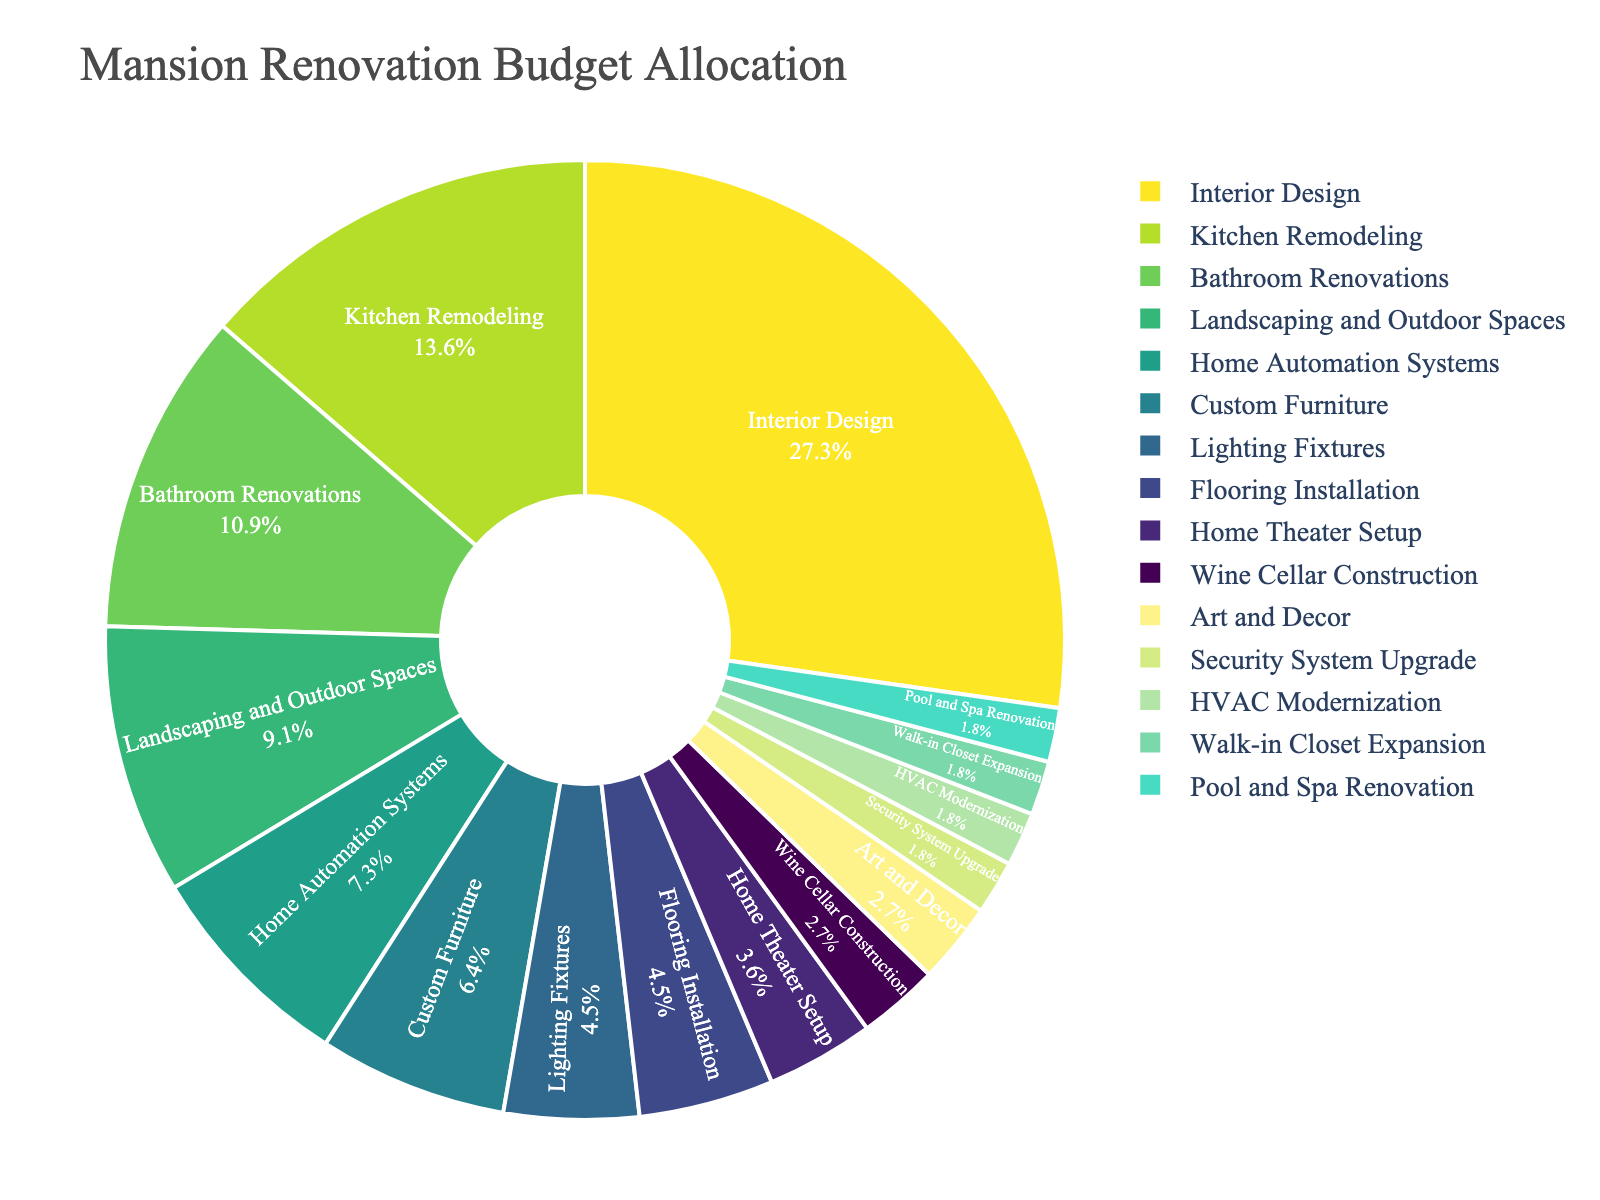What percentage of the budget is allocated to Interior Design? Look at the slice labeled "Interior Design" in the pie chart and read the percentage value directly.
Answer: 30% Is the budget for Kitchen Remodeling greater than that for Bathroom Renovations? Compare the slices labeled "Kitchen Remodeling" and "Bathroom Renovations" in the pie chart. Kitchen Remodeling has a budget of 15%, while Bathroom Renovations have 12%.
Answer: Yes What is the combined budget allocation for Lighting Fixtures, Flooring Installation, and Home Theater Setup? Sum the individual percentages from the pie chart. Lighting Fixtures (5%) + Flooring Installation (5%) + Home Theater Setup (4%) = 14%.
Answer: 14% How much more budget percentage is allocated to Landscaping and Outdoor Spaces compared to Wine Cellar Construction? Subtract the budget percentage of Wine Cellar Construction (3%) from Landscaping and Outdoor Spaces (10%). 10% - 3% = 7%.
Answer: 7% Which has a higher budget allocation, Custom Furniture or Home Automation Systems? Compare the slices for Custom Furniture (7%) and Home Automation Systems (8%) in the pie chart.
Answer: Home Automation Systems Rank the following areas from highest to lowest by budget allocation: Art and Decor, HVAC Modernization, Walk-in Closet Expansion. Refer to the individual slices for Art and Decor (3%), HVAC Modernization (2%), and Walk-in Closet Expansion (2%) in the pie chart and rank them accordingly.
Answer: Art and Decor, HVAC Modernization, Walk-in Closet Expansion Which area has the least budget allocation, and what is its percentage? Identify the smallest slice in the pie chart. The Security System Upgrade has the smallest slice with a 2% allocation.
Answer: Security System Upgrade, 2% What is the difference in budget allocation between the areas with the highest and lowest allocations? The highest budget allocation is for Interior Design (30%), and the lowest allocations, each at 2%, are Security System Upgrade, HVAC Modernization, Walk-in Closet Expansion, and Pool and Spa Renovation. Subtract the lowest percentage from the highest: 30% - 2% = 28%.
Answer: 28% Identify the total budget allocation for areas with an individual allocation of less than or equal to 5%. Sum the budget allocations for areas that meet the criteria: Lighting Fixtures (5%) + Flooring Installation (5%) + Home Theater Setup (4%) + Wine Cellar Construction (3%) + Art and Decor (3%) + Security System Upgrade (2%) + HVAC Modernization (2%) + Walk-in Closet Expansion (2%) + Pool and Spa Renovation (2%) = 28%.
Answer: 28% Does the budget allocation for Pool and Spa Renovation exceed that of Home Theater Setup? Compare the slices labeled "Pool and Spa Renovation" (2%) and "Home Theater Setup" (4%) in the pie chart.
Answer: No 